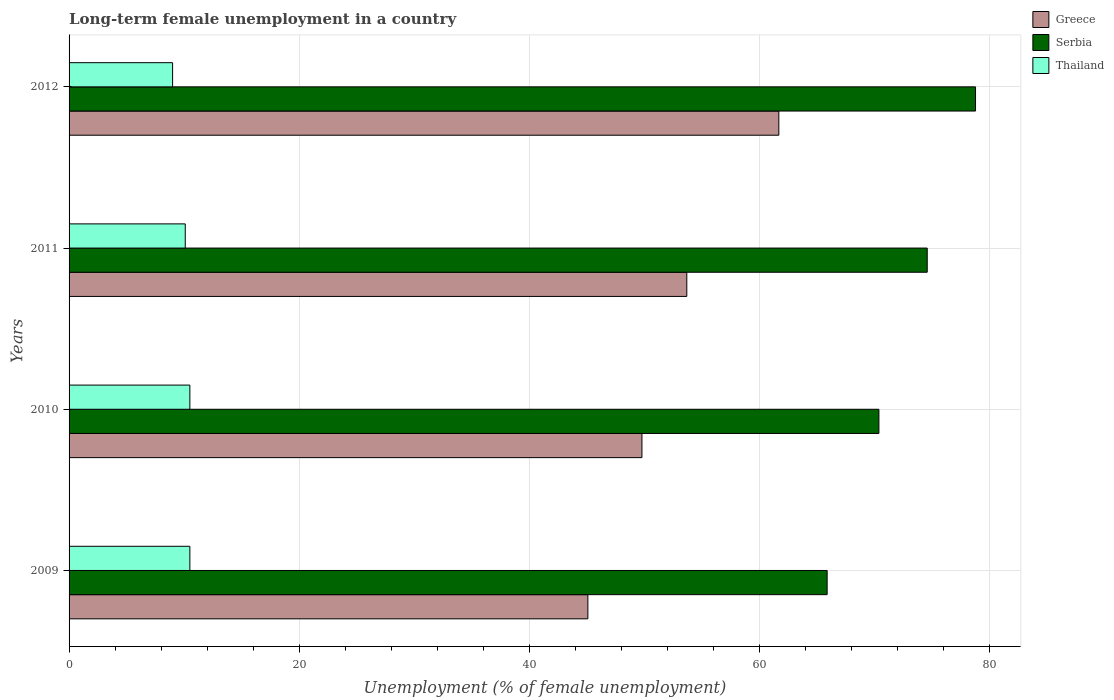How many bars are there on the 1st tick from the top?
Your answer should be compact. 3. What is the label of the 1st group of bars from the top?
Your response must be concise. 2012. What is the percentage of long-term unemployed female population in Serbia in 2009?
Your answer should be compact. 65.9. Across all years, what is the maximum percentage of long-term unemployed female population in Thailand?
Offer a very short reply. 10.5. In which year was the percentage of long-term unemployed female population in Greece maximum?
Provide a succinct answer. 2012. In which year was the percentage of long-term unemployed female population in Greece minimum?
Give a very brief answer. 2009. What is the total percentage of long-term unemployed female population in Thailand in the graph?
Give a very brief answer. 40.1. What is the difference between the percentage of long-term unemployed female population in Serbia in 2011 and that in 2012?
Offer a terse response. -4.2. What is the difference between the percentage of long-term unemployed female population in Greece in 2009 and the percentage of long-term unemployed female population in Serbia in 2011?
Your response must be concise. -29.5. What is the average percentage of long-term unemployed female population in Serbia per year?
Provide a succinct answer. 72.43. In the year 2009, what is the difference between the percentage of long-term unemployed female population in Greece and percentage of long-term unemployed female population in Serbia?
Keep it short and to the point. -20.8. What is the ratio of the percentage of long-term unemployed female population in Thailand in 2009 to that in 2012?
Give a very brief answer. 1.17. What is the difference between the highest and the second highest percentage of long-term unemployed female population in Serbia?
Give a very brief answer. 4.2. What is the difference between the highest and the lowest percentage of long-term unemployed female population in Greece?
Give a very brief answer. 16.6. In how many years, is the percentage of long-term unemployed female population in Greece greater than the average percentage of long-term unemployed female population in Greece taken over all years?
Provide a short and direct response. 2. Is the sum of the percentage of long-term unemployed female population in Greece in 2010 and 2012 greater than the maximum percentage of long-term unemployed female population in Thailand across all years?
Provide a succinct answer. Yes. What does the 3rd bar from the top in 2012 represents?
Your answer should be very brief. Greece. What does the 3rd bar from the bottom in 2012 represents?
Offer a very short reply. Thailand. Is it the case that in every year, the sum of the percentage of long-term unemployed female population in Serbia and percentage of long-term unemployed female population in Thailand is greater than the percentage of long-term unemployed female population in Greece?
Offer a terse response. Yes. How many bars are there?
Offer a terse response. 12. How many years are there in the graph?
Your answer should be very brief. 4. What is the difference between two consecutive major ticks on the X-axis?
Keep it short and to the point. 20. Where does the legend appear in the graph?
Give a very brief answer. Top right. How many legend labels are there?
Your response must be concise. 3. How are the legend labels stacked?
Your response must be concise. Vertical. What is the title of the graph?
Give a very brief answer. Long-term female unemployment in a country. Does "St. Lucia" appear as one of the legend labels in the graph?
Your answer should be very brief. No. What is the label or title of the X-axis?
Give a very brief answer. Unemployment (% of female unemployment). What is the Unemployment (% of female unemployment) in Greece in 2009?
Provide a succinct answer. 45.1. What is the Unemployment (% of female unemployment) in Serbia in 2009?
Offer a terse response. 65.9. What is the Unemployment (% of female unemployment) of Thailand in 2009?
Offer a very short reply. 10.5. What is the Unemployment (% of female unemployment) in Greece in 2010?
Make the answer very short. 49.8. What is the Unemployment (% of female unemployment) of Serbia in 2010?
Keep it short and to the point. 70.4. What is the Unemployment (% of female unemployment) of Greece in 2011?
Offer a terse response. 53.7. What is the Unemployment (% of female unemployment) in Serbia in 2011?
Offer a very short reply. 74.6. What is the Unemployment (% of female unemployment) in Thailand in 2011?
Your answer should be very brief. 10.1. What is the Unemployment (% of female unemployment) in Greece in 2012?
Offer a terse response. 61.7. What is the Unemployment (% of female unemployment) of Serbia in 2012?
Provide a short and direct response. 78.8. What is the Unemployment (% of female unemployment) in Thailand in 2012?
Give a very brief answer. 9. Across all years, what is the maximum Unemployment (% of female unemployment) in Greece?
Offer a very short reply. 61.7. Across all years, what is the maximum Unemployment (% of female unemployment) of Serbia?
Your answer should be compact. 78.8. Across all years, what is the maximum Unemployment (% of female unemployment) in Thailand?
Provide a short and direct response. 10.5. Across all years, what is the minimum Unemployment (% of female unemployment) in Greece?
Your answer should be compact. 45.1. Across all years, what is the minimum Unemployment (% of female unemployment) in Serbia?
Offer a very short reply. 65.9. What is the total Unemployment (% of female unemployment) in Greece in the graph?
Give a very brief answer. 210.3. What is the total Unemployment (% of female unemployment) in Serbia in the graph?
Offer a very short reply. 289.7. What is the total Unemployment (% of female unemployment) in Thailand in the graph?
Provide a succinct answer. 40.1. What is the difference between the Unemployment (% of female unemployment) in Greece in 2009 and that in 2010?
Make the answer very short. -4.7. What is the difference between the Unemployment (% of female unemployment) in Greece in 2009 and that in 2011?
Make the answer very short. -8.6. What is the difference between the Unemployment (% of female unemployment) of Serbia in 2009 and that in 2011?
Keep it short and to the point. -8.7. What is the difference between the Unemployment (% of female unemployment) of Greece in 2009 and that in 2012?
Provide a succinct answer. -16.6. What is the difference between the Unemployment (% of female unemployment) of Thailand in 2009 and that in 2012?
Make the answer very short. 1.5. What is the difference between the Unemployment (% of female unemployment) in Serbia in 2010 and that in 2011?
Ensure brevity in your answer.  -4.2. What is the difference between the Unemployment (% of female unemployment) in Greece in 2010 and that in 2012?
Ensure brevity in your answer.  -11.9. What is the difference between the Unemployment (% of female unemployment) in Serbia in 2010 and that in 2012?
Your answer should be compact. -8.4. What is the difference between the Unemployment (% of female unemployment) of Greece in 2009 and the Unemployment (% of female unemployment) of Serbia in 2010?
Make the answer very short. -25.3. What is the difference between the Unemployment (% of female unemployment) in Greece in 2009 and the Unemployment (% of female unemployment) in Thailand in 2010?
Your answer should be very brief. 34.6. What is the difference between the Unemployment (% of female unemployment) of Serbia in 2009 and the Unemployment (% of female unemployment) of Thailand in 2010?
Your answer should be very brief. 55.4. What is the difference between the Unemployment (% of female unemployment) of Greece in 2009 and the Unemployment (% of female unemployment) of Serbia in 2011?
Your answer should be compact. -29.5. What is the difference between the Unemployment (% of female unemployment) in Serbia in 2009 and the Unemployment (% of female unemployment) in Thailand in 2011?
Your answer should be compact. 55.8. What is the difference between the Unemployment (% of female unemployment) in Greece in 2009 and the Unemployment (% of female unemployment) in Serbia in 2012?
Your answer should be compact. -33.7. What is the difference between the Unemployment (% of female unemployment) in Greece in 2009 and the Unemployment (% of female unemployment) in Thailand in 2012?
Give a very brief answer. 36.1. What is the difference between the Unemployment (% of female unemployment) of Serbia in 2009 and the Unemployment (% of female unemployment) of Thailand in 2012?
Make the answer very short. 56.9. What is the difference between the Unemployment (% of female unemployment) of Greece in 2010 and the Unemployment (% of female unemployment) of Serbia in 2011?
Provide a short and direct response. -24.8. What is the difference between the Unemployment (% of female unemployment) in Greece in 2010 and the Unemployment (% of female unemployment) in Thailand in 2011?
Offer a very short reply. 39.7. What is the difference between the Unemployment (% of female unemployment) in Serbia in 2010 and the Unemployment (% of female unemployment) in Thailand in 2011?
Make the answer very short. 60.3. What is the difference between the Unemployment (% of female unemployment) of Greece in 2010 and the Unemployment (% of female unemployment) of Serbia in 2012?
Provide a succinct answer. -29. What is the difference between the Unemployment (% of female unemployment) in Greece in 2010 and the Unemployment (% of female unemployment) in Thailand in 2012?
Your response must be concise. 40.8. What is the difference between the Unemployment (% of female unemployment) of Serbia in 2010 and the Unemployment (% of female unemployment) of Thailand in 2012?
Provide a succinct answer. 61.4. What is the difference between the Unemployment (% of female unemployment) in Greece in 2011 and the Unemployment (% of female unemployment) in Serbia in 2012?
Your answer should be compact. -25.1. What is the difference between the Unemployment (% of female unemployment) in Greece in 2011 and the Unemployment (% of female unemployment) in Thailand in 2012?
Keep it short and to the point. 44.7. What is the difference between the Unemployment (% of female unemployment) in Serbia in 2011 and the Unemployment (% of female unemployment) in Thailand in 2012?
Provide a succinct answer. 65.6. What is the average Unemployment (% of female unemployment) of Greece per year?
Provide a short and direct response. 52.58. What is the average Unemployment (% of female unemployment) of Serbia per year?
Give a very brief answer. 72.42. What is the average Unemployment (% of female unemployment) of Thailand per year?
Offer a terse response. 10.03. In the year 2009, what is the difference between the Unemployment (% of female unemployment) in Greece and Unemployment (% of female unemployment) in Serbia?
Offer a very short reply. -20.8. In the year 2009, what is the difference between the Unemployment (% of female unemployment) in Greece and Unemployment (% of female unemployment) in Thailand?
Give a very brief answer. 34.6. In the year 2009, what is the difference between the Unemployment (% of female unemployment) of Serbia and Unemployment (% of female unemployment) of Thailand?
Give a very brief answer. 55.4. In the year 2010, what is the difference between the Unemployment (% of female unemployment) in Greece and Unemployment (% of female unemployment) in Serbia?
Your answer should be compact. -20.6. In the year 2010, what is the difference between the Unemployment (% of female unemployment) in Greece and Unemployment (% of female unemployment) in Thailand?
Your response must be concise. 39.3. In the year 2010, what is the difference between the Unemployment (% of female unemployment) in Serbia and Unemployment (% of female unemployment) in Thailand?
Offer a terse response. 59.9. In the year 2011, what is the difference between the Unemployment (% of female unemployment) of Greece and Unemployment (% of female unemployment) of Serbia?
Your answer should be very brief. -20.9. In the year 2011, what is the difference between the Unemployment (% of female unemployment) of Greece and Unemployment (% of female unemployment) of Thailand?
Your response must be concise. 43.6. In the year 2011, what is the difference between the Unemployment (% of female unemployment) in Serbia and Unemployment (% of female unemployment) in Thailand?
Provide a short and direct response. 64.5. In the year 2012, what is the difference between the Unemployment (% of female unemployment) of Greece and Unemployment (% of female unemployment) of Serbia?
Your answer should be compact. -17.1. In the year 2012, what is the difference between the Unemployment (% of female unemployment) in Greece and Unemployment (% of female unemployment) in Thailand?
Provide a short and direct response. 52.7. In the year 2012, what is the difference between the Unemployment (% of female unemployment) of Serbia and Unemployment (% of female unemployment) of Thailand?
Your response must be concise. 69.8. What is the ratio of the Unemployment (% of female unemployment) of Greece in 2009 to that in 2010?
Provide a short and direct response. 0.91. What is the ratio of the Unemployment (% of female unemployment) of Serbia in 2009 to that in 2010?
Keep it short and to the point. 0.94. What is the ratio of the Unemployment (% of female unemployment) in Greece in 2009 to that in 2011?
Offer a very short reply. 0.84. What is the ratio of the Unemployment (% of female unemployment) in Serbia in 2009 to that in 2011?
Provide a short and direct response. 0.88. What is the ratio of the Unemployment (% of female unemployment) in Thailand in 2009 to that in 2011?
Provide a succinct answer. 1.04. What is the ratio of the Unemployment (% of female unemployment) in Greece in 2009 to that in 2012?
Your answer should be very brief. 0.73. What is the ratio of the Unemployment (% of female unemployment) in Serbia in 2009 to that in 2012?
Provide a short and direct response. 0.84. What is the ratio of the Unemployment (% of female unemployment) of Greece in 2010 to that in 2011?
Keep it short and to the point. 0.93. What is the ratio of the Unemployment (% of female unemployment) in Serbia in 2010 to that in 2011?
Provide a short and direct response. 0.94. What is the ratio of the Unemployment (% of female unemployment) of Thailand in 2010 to that in 2011?
Provide a short and direct response. 1.04. What is the ratio of the Unemployment (% of female unemployment) of Greece in 2010 to that in 2012?
Make the answer very short. 0.81. What is the ratio of the Unemployment (% of female unemployment) of Serbia in 2010 to that in 2012?
Your answer should be very brief. 0.89. What is the ratio of the Unemployment (% of female unemployment) in Thailand in 2010 to that in 2012?
Provide a succinct answer. 1.17. What is the ratio of the Unemployment (% of female unemployment) in Greece in 2011 to that in 2012?
Offer a terse response. 0.87. What is the ratio of the Unemployment (% of female unemployment) in Serbia in 2011 to that in 2012?
Make the answer very short. 0.95. What is the ratio of the Unemployment (% of female unemployment) of Thailand in 2011 to that in 2012?
Make the answer very short. 1.12. What is the difference between the highest and the second highest Unemployment (% of female unemployment) in Greece?
Give a very brief answer. 8. What is the difference between the highest and the second highest Unemployment (% of female unemployment) of Thailand?
Ensure brevity in your answer.  0. What is the difference between the highest and the lowest Unemployment (% of female unemployment) in Greece?
Your response must be concise. 16.6. What is the difference between the highest and the lowest Unemployment (% of female unemployment) of Thailand?
Provide a short and direct response. 1.5. 